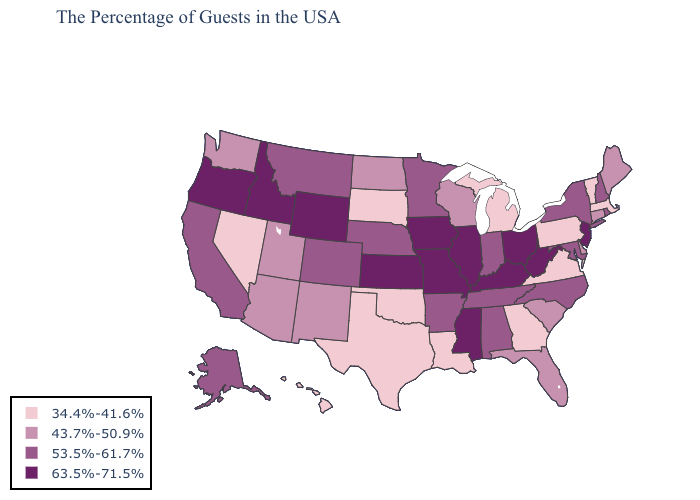Among the states that border Montana , which have the highest value?
Quick response, please. Wyoming, Idaho. Among the states that border Indiana , does Ohio have the highest value?
Short answer required. Yes. What is the highest value in states that border Oregon?
Answer briefly. 63.5%-71.5%. Name the states that have a value in the range 34.4%-41.6%?
Be succinct. Massachusetts, Vermont, Pennsylvania, Virginia, Georgia, Michigan, Louisiana, Oklahoma, Texas, South Dakota, Nevada, Hawaii. What is the value of Oklahoma?
Be succinct. 34.4%-41.6%. Does North Carolina have a lower value than Idaho?
Be succinct. Yes. What is the value of Illinois?
Quick response, please. 63.5%-71.5%. Which states hav the highest value in the West?
Concise answer only. Wyoming, Idaho, Oregon. Name the states that have a value in the range 53.5%-61.7%?
Quick response, please. Rhode Island, New Hampshire, New York, Maryland, North Carolina, Indiana, Alabama, Tennessee, Arkansas, Minnesota, Nebraska, Colorado, Montana, California, Alaska. Which states have the highest value in the USA?
Keep it brief. New Jersey, West Virginia, Ohio, Kentucky, Illinois, Mississippi, Missouri, Iowa, Kansas, Wyoming, Idaho, Oregon. What is the value of Florida?
Write a very short answer. 43.7%-50.9%. Name the states that have a value in the range 53.5%-61.7%?
Answer briefly. Rhode Island, New Hampshire, New York, Maryland, North Carolina, Indiana, Alabama, Tennessee, Arkansas, Minnesota, Nebraska, Colorado, Montana, California, Alaska. Name the states that have a value in the range 34.4%-41.6%?
Answer briefly. Massachusetts, Vermont, Pennsylvania, Virginia, Georgia, Michigan, Louisiana, Oklahoma, Texas, South Dakota, Nevada, Hawaii. Does the first symbol in the legend represent the smallest category?
Quick response, please. Yes. Name the states that have a value in the range 43.7%-50.9%?
Answer briefly. Maine, Connecticut, Delaware, South Carolina, Florida, Wisconsin, North Dakota, New Mexico, Utah, Arizona, Washington. 